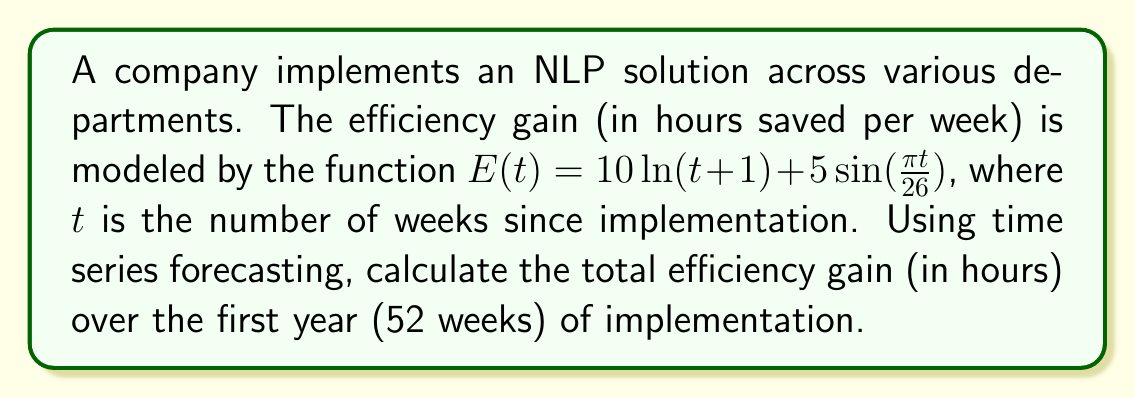Show me your answer to this math problem. To solve this problem, we need to follow these steps:

1) The total efficiency gain over 52 weeks is the integral of the function $E(t)$ from $t=0$ to $t=52$.

2) Let's break down the integral:

   $$\int_0^{52} E(t) dt = \int_0^{52} [10\ln(t+1) + 5\sin(\frac{\pi t}{26})] dt$$

3) We can split this into two integrals:

   $$\int_0^{52} 10\ln(t+1) dt + \int_0^{52} 5\sin(\frac{\pi t}{26}) dt$$

4) For the first integral:
   
   $$10\int_0^{52} \ln(t+1) dt = 10[(t+1)\ln(t+1) - t]_0^{52}$$
   $$= 10[(53\ln(53) - 52) - (1\ln(1) - 0)]$$
   $$= 10[53\ln(53) - 52]$$

5) For the second integral:
   
   $$5\int_0^{52} \sin(\frac{\pi t}{26}) dt = -\frac{130}{\pi}[\cos(\frac{\pi t}{26})]_0^{52}$$
   $$= -\frac{130}{\pi}[\cos(2\pi) - \cos(0)]$$
   $$= -\frac{130}{\pi}[1 - 1] = 0$$

6) Adding the results from steps 4 and 5:

   Total efficiency gain = $10[53\ln(53) - 52] + 0$

7) Calculating this value:

   $10[53\ln(53) - 52] \approx 1998.72$ hours
Answer: 1998.72 hours 